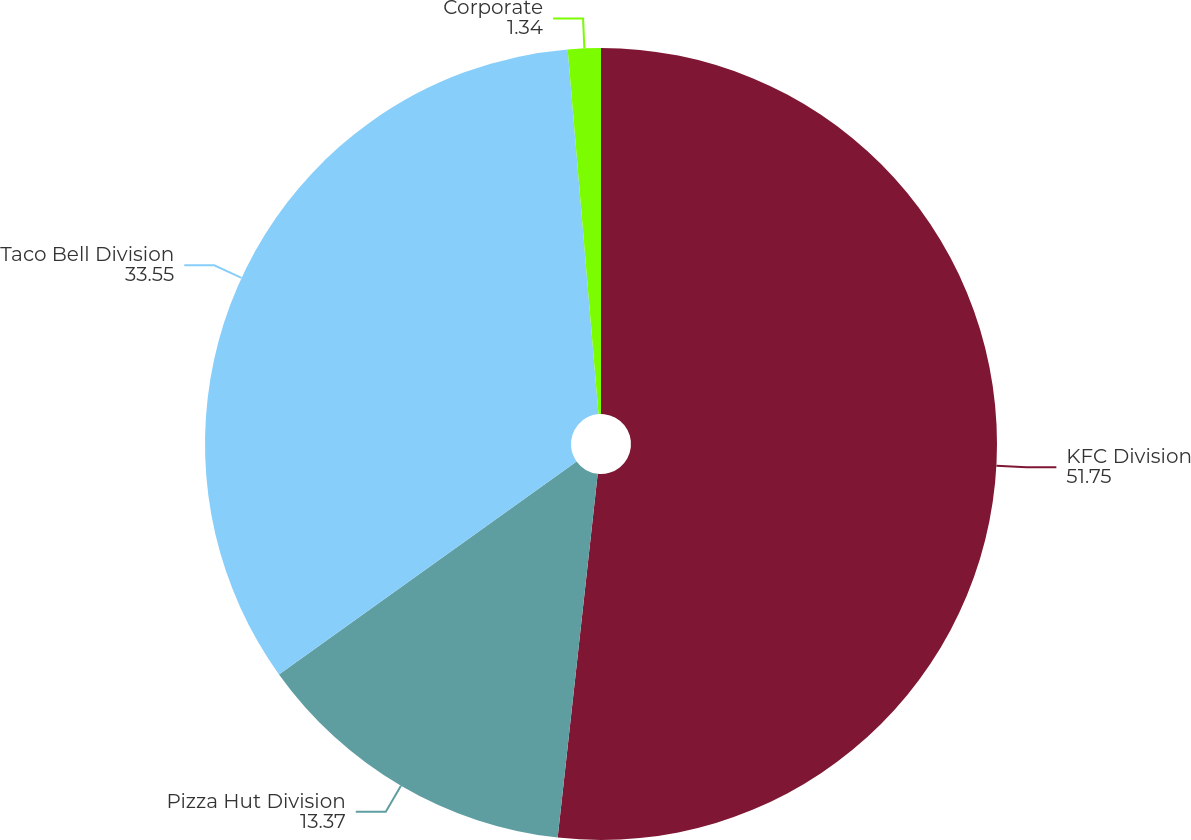Convert chart. <chart><loc_0><loc_0><loc_500><loc_500><pie_chart><fcel>KFC Division<fcel>Pizza Hut Division<fcel>Taco Bell Division<fcel>Corporate<nl><fcel>51.75%<fcel>13.37%<fcel>33.55%<fcel>1.34%<nl></chart> 